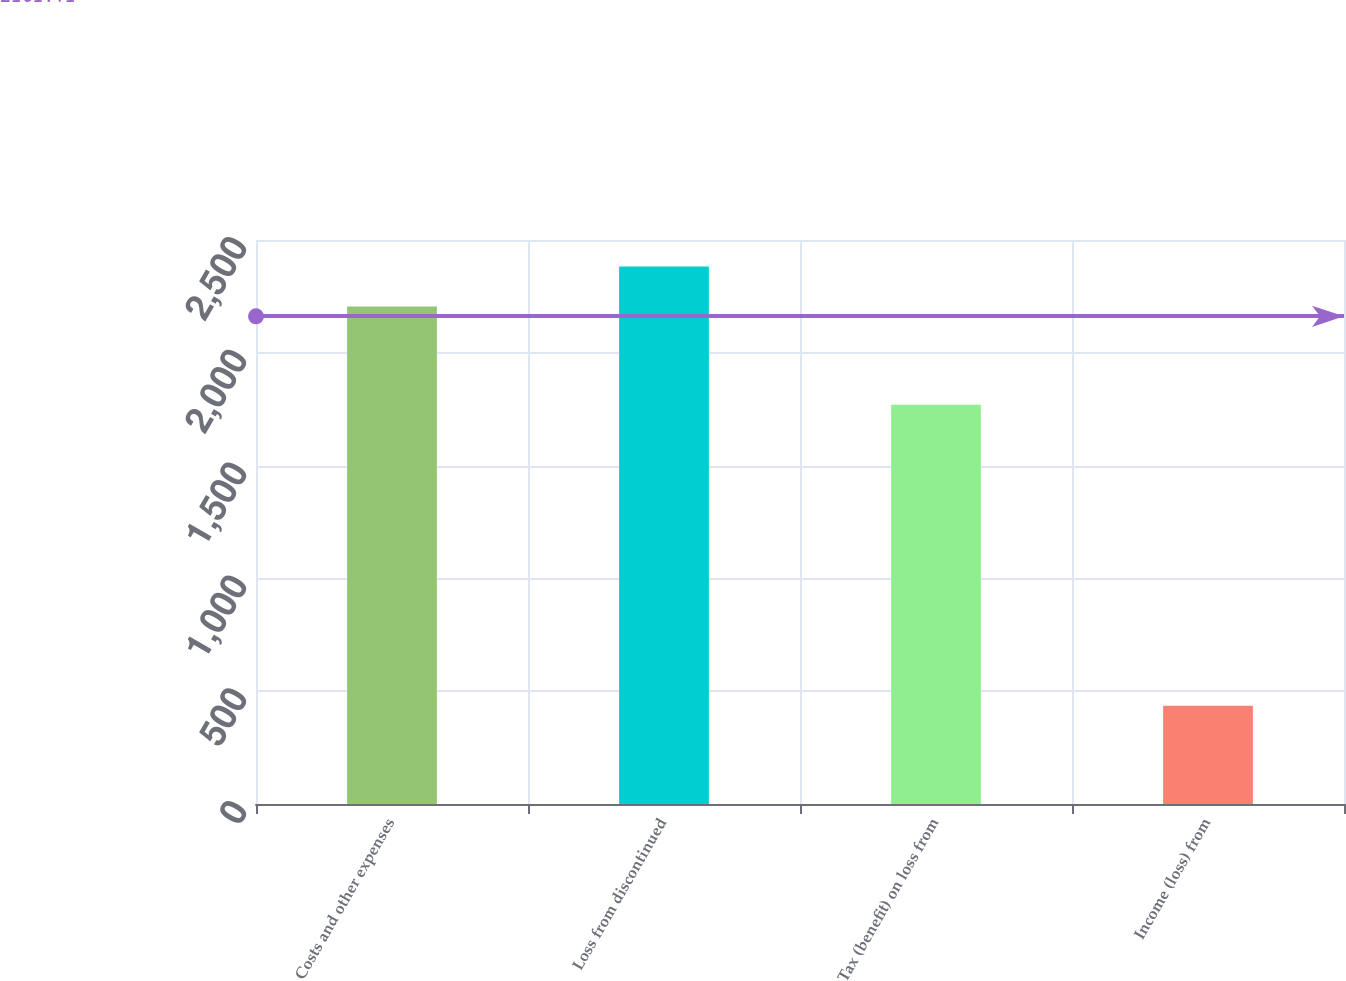Convert chart to OTSL. <chart><loc_0><loc_0><loc_500><loc_500><bar_chart><fcel>Costs and other expenses<fcel>Loss from discontinued<fcel>Tax (benefit) on loss from<fcel>Income (loss) from<nl><fcel>2205<fcel>2382<fcel>1770<fcel>435<nl></chart> 